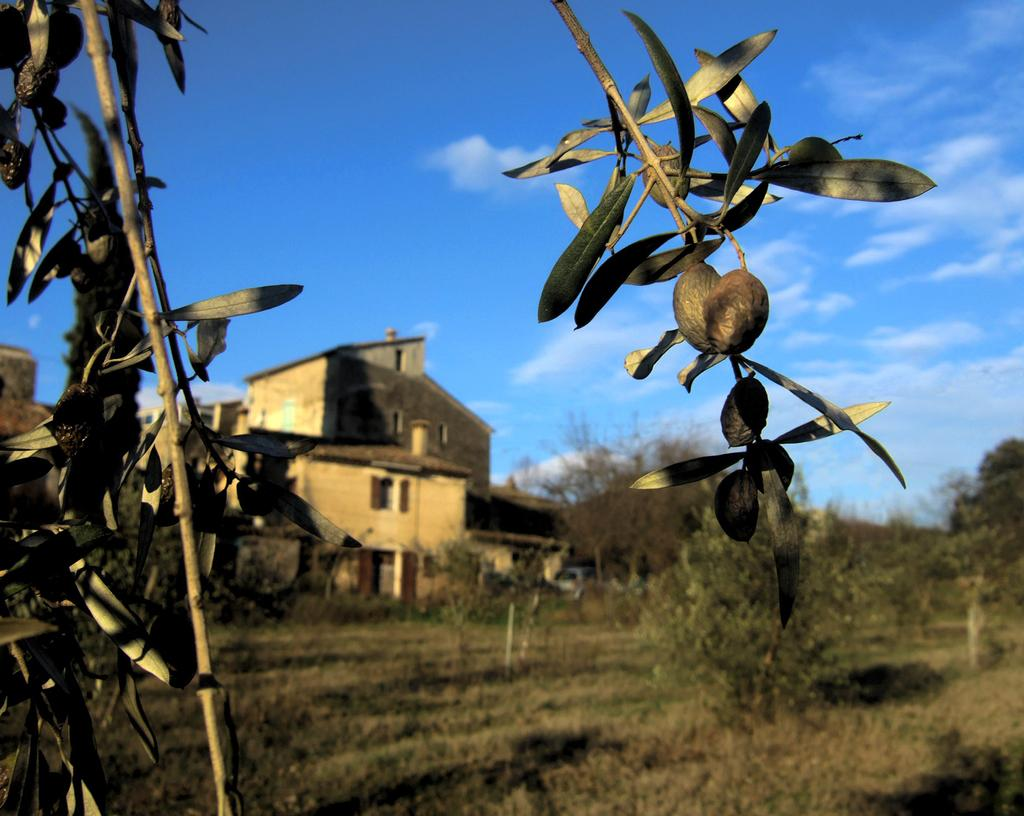What type of buildings can be seen in the image? There are houses in the image. What other natural elements are present in the image? There are trees in the image. What is the color of the sky in the image? The sky is blue and white in color. Is there any vegetation visible in the image? Yes, there is a plant visible in the image. Can you see a twig being used as a prop in the image? There is no twig present in the image. What type of structure is being showcased in the image? The image does not showcase any specific structure; it features houses, trees, and a plant. 